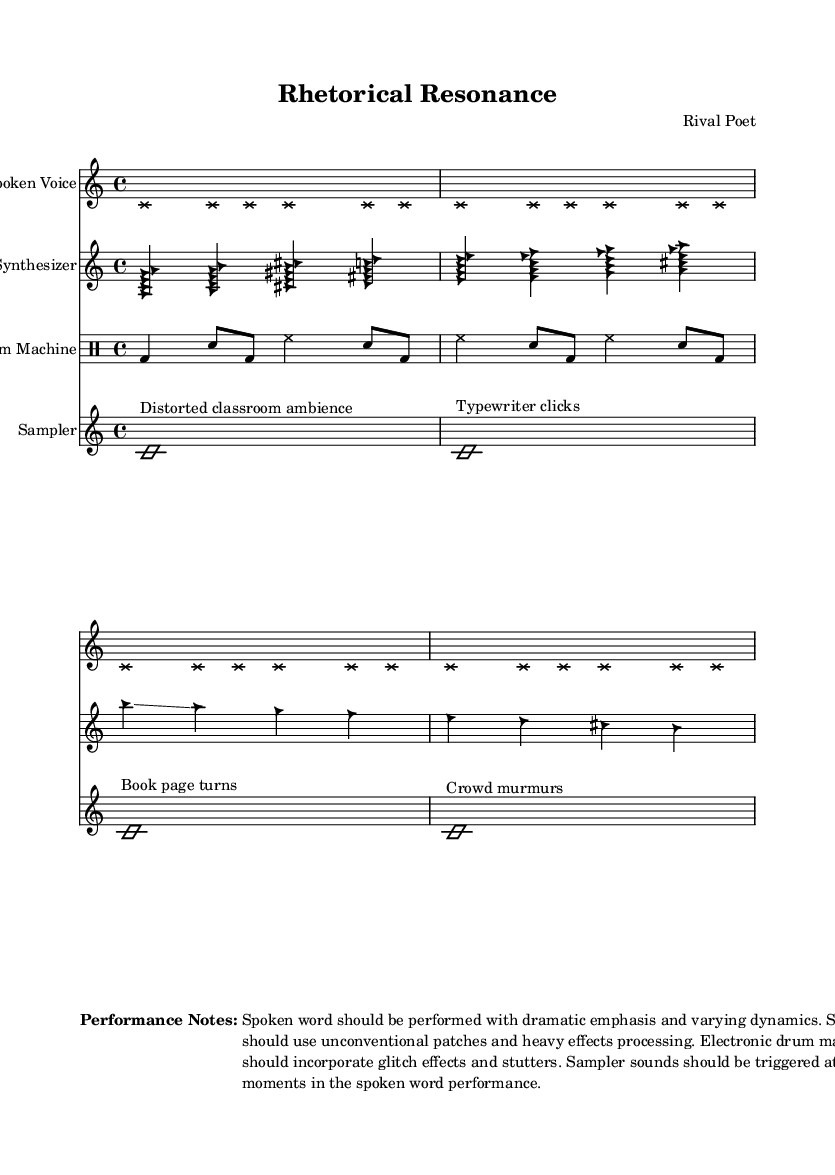What is the time signature of this piece? The time signature is indicated at the beginning of the vocal and instrumental staves as 4/4.
Answer: 4/4 What instruments are featured in the score? The score includes a Spoken Voice, Synthesizer, Drum Machine, and Sampler, as noted in the headings of each staff.
Answer: Spoken Voice, Synthesizer, Drum Machine, Sampler How many measures are in the spoken voice section? Counting the groups of notes in the spoken voice section reveals four measures, as indicated by the rhythmic structure of the notation.
Answer: Four What type of sound is used for the spoken voice? The spoken voice is represented with cross note heads and is specifically meant to convey dramatic emphasis and varying dynamics, as noted in the performance instructions.
Answer: Dramatic emphasis What effects should the synthesizer use according to the performance notes? The performance notes specify that the synthesizer should use unconventional patches and heavy effects processing, indicating an experimental approach to sound design.
Answer: Unconventional patches and heavy effects processing How does the sampler function in this piece? The sampler is used to trigger various ambient sound effects, such as distorted classroom ambience and typewriter clicks, at key moments during the spoken performance.
Answer: Trigger ambient sound effects What rhythmic pattern does the drum machine employ? The drum machine uses a combination of bass drum, snare, and hi-hat patterns, characterized by regular quarter notes and eighth notes arranged in a repetitive rhythm.
Answer: Bass drum, snare, hi-hat patterns 